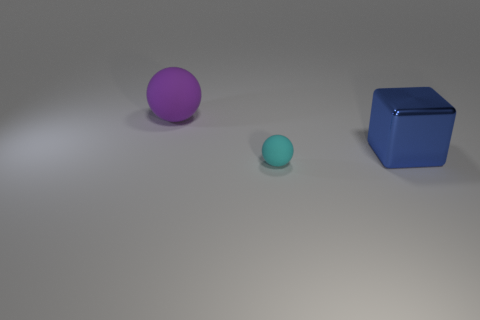Add 3 metal things. How many objects exist? 6 Subtract all cubes. How many objects are left? 2 Subtract all large spheres. Subtract all big blue things. How many objects are left? 1 Add 1 metal cubes. How many metal cubes are left? 2 Add 2 large metallic things. How many large metallic things exist? 3 Subtract 0 gray blocks. How many objects are left? 3 